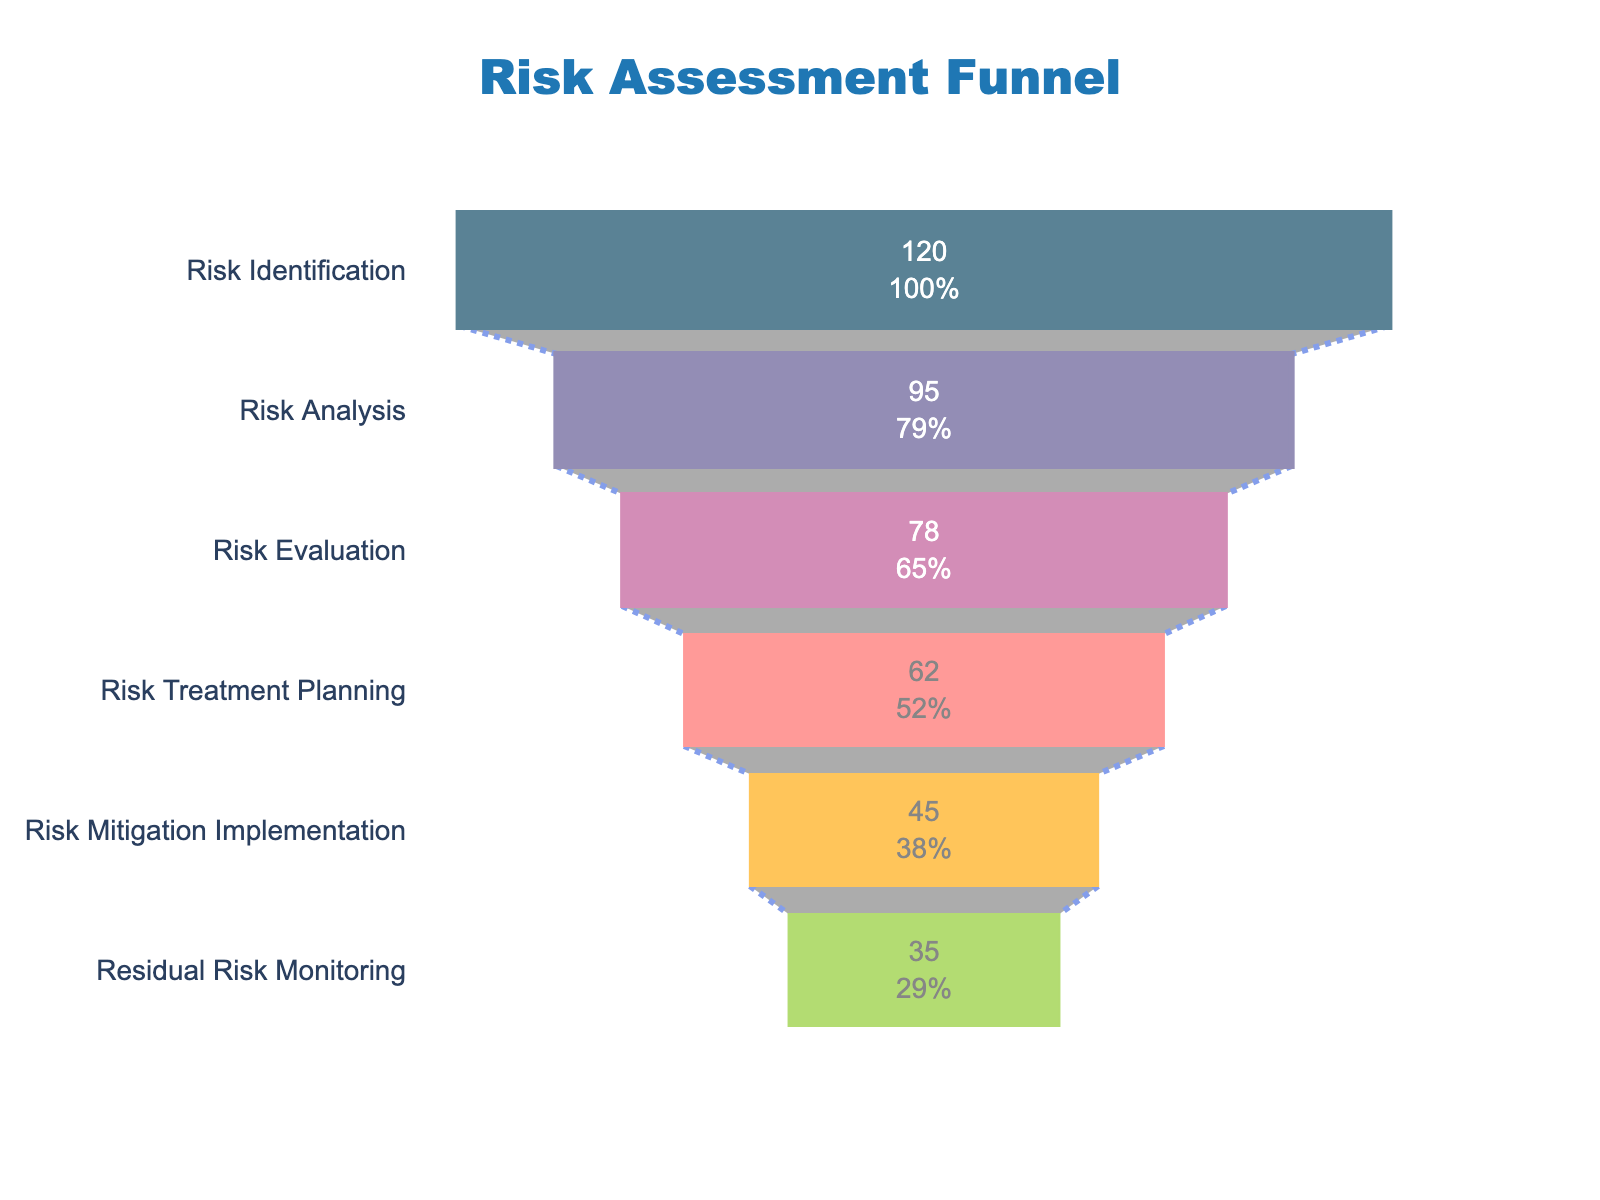How many stages are presented in the funnel chart? The chart represents each stage in the risk assessment process, which are visually distinct segments of the funnel. Count these segments to determine the total number.
Answer: Six What is the total number of risks identified in the initial 'Risk Identification' stage? The 'Risk Identification' stage is at the top of the funnel, and its corresponding number of risks is labeled within the segment.
Answer: 120 What is the percentage decrease in the number of risks from 'Risk Identification' to 'Risk Analysis'? Calculate the decrease by subtracting the number of risks in 'Risk Analysis' from 'Risk Identification', then divide by the number in 'Risk Identification' and multiply by 100 to get the percentage. (120 - 95) / 120 * 100 = 20.83%
Answer: 20.83% Which stage has the lowest number of risks? Identify the segment in the funnel that represents the stage with the smallest value.
Answer: Residual Risk Monitoring What is the difference in the number of risks between 'Risk Treatment Planning' and 'Risk Mitigation Implementation'? Subtract the number of risks in 'Risk Mitigation Implementation' from the number in 'Risk Treatment Planning'. 62 - 45 = 17
Answer: 17 When moving from 'Risk Evaluation' to 'Risk Treatment Planning', how much does the number of risks decrease in percentage terms? Calculate the percentage decrease by taking the difference between the risks in 'Risk Evaluation' and 'Risk Treatment Planning', then divide by the number in 'Risk Evaluation' and multiply by 100. (78 - 62) / 78 * 100 = 20.51%
Answer: 20.51% What is the cumulative decrease in the number of risks from 'Risk Identification' to 'Residual Risk Monitoring'? Subtract the number of risks in 'Residual Risk Monitoring' from the number in 'Risk Identification'. 120 - 35 = 85
Answer: 85 Which stage has more risks: 'Risk Treatment Planning' or 'Residual Risk Monitoring'? Identify the number of risks in each stage and compare them. 'Risk Treatment Planning' has 62, while 'Residual Risk Monitoring' has 35.
Answer: Risk Treatment Planning What percentage of the initially identified risks remain at the 'Risk Mitigation Implementation' stage? Divide the number of risks in 'Risk Mitigation Implementation' by the number in 'Risk Identification' and multiply by 100. 45 / 120 * 100 = 37.5%
Answer: 37.5% Explain the overall trend of the risk numbers through the stages of the funnel. Observe the values in each stage and note that the number of risks generally decreases as the stages progress, from identification to the final monitoring phase.
Answer: The number of risks decreases 